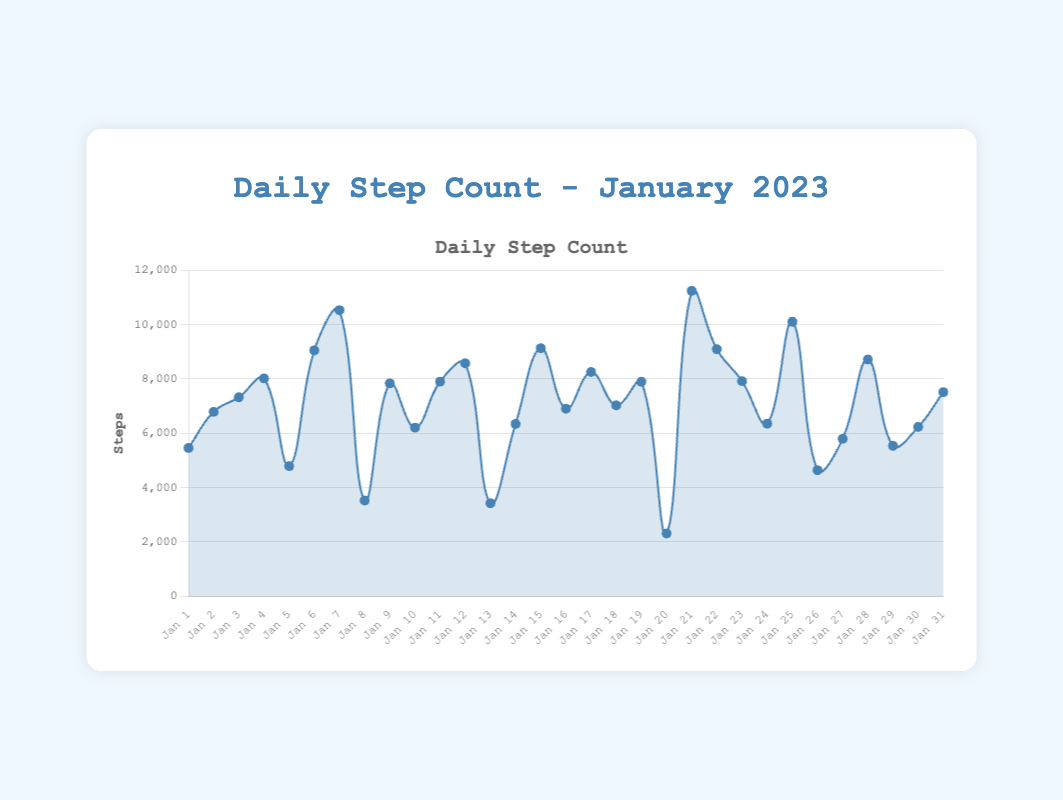How many days had a step count greater than 9000? Count the number of days where the step value exceeds 9000. There are 5 days: Jan 7, Jan 15, Jan 21, Jan 25, and Jan 22.
Answer: 5 days What is the average daily step count for January 2023? Sum all daily step counts and divide by the number of days. The total steps are 205639, and there are 31 days, so the average is 205639/31 ≈ 6633.51.
Answer: 6633.51 Which day had the highest step count and how many steps were recorded? Identify the peak of the line chart. The highest step count is on Jan 21 with 11234 steps.
Answer: Jan 21, 11234 steps Compare the step counts of January 14 and January 28. Which is higher? Look at the points for Jan 14 (6341 steps) and Jan 28 (8710 steps) and compare them. January 28 is higher.
Answer: January 28 What is the total step count for all weekends in January 2023? Sum up step counts for all weekends (Jan 7, Jan 8, Jan 14, Jan 15, Jan 21, Jan 22, Jan 28, Jan 29). The total is 10523 + 3521 + 6341 + 9125 + 11234 + 9087 + 8710 + 5533 = 60074.
Answer: 60074 On which day did the step count drop to the lowest, and how many steps were recorded? Find the lowest point on the line chart. The lowest step count is on Jan 20 with 2310 steps.
Answer: Jan 20, 2310 steps Find the range of daily step counts in January 2023. Subtract the smallest step count (2310 on Jan 20) from the highest step count (11234 on Jan 21). The range is 11234 - 2310 = 8924.
Answer: 8924 What is the step count difference between the highest and the lowest day of the month? The highest step count is 11234 on Jan 21, and the lowest is 2310 on Jan 20. The difference is 11234 - 2310 = 8924.
Answer: 8924 On which dates did the step count exceed 10000? Identify days where the step count is greater than 10000. These dates are Jan 7, Jan 21, and Jan 25.
Answer: Jan 7, Jan 21, Jan 25 